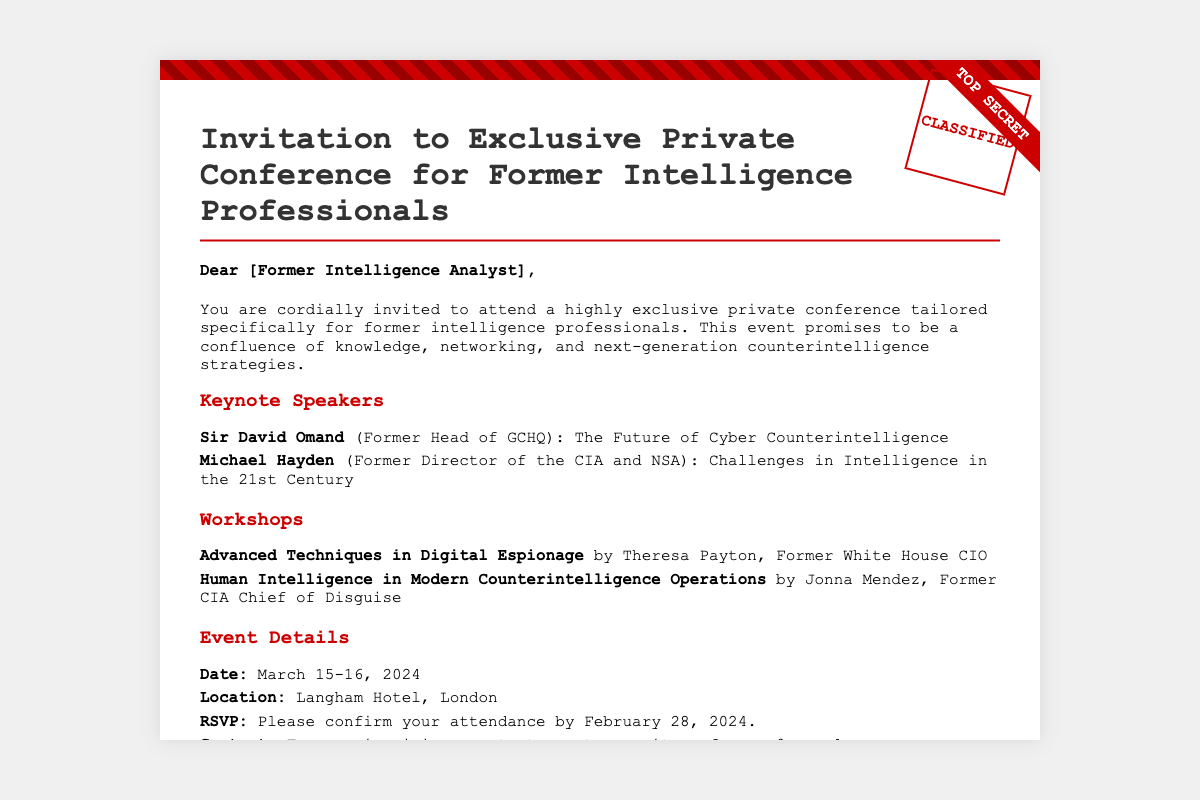What is the date of the conference? The date of the conference is clearly stated in the document under Event Details.
Answer: March 15-16, 2024 Who is the keynote speaker representing GCHQ? The document specifies the keynote speakers, including the one from GCHQ.
Answer: Sir David Omand What is the location of the conference? The location is provided in the Event Details section of the document.
Answer: Langham Hotel, London What workshop is led by the former White House CIO? The document lists workshops, identifying the one led by Theresa Payton.
Answer: Advanced Techniques in Digital Espionage By when do you need to RSVP? The RSVP deadline is mentioned in the Event Details section.
Answer: February 28, 2024 What phrase is used to denote the classification of the invitation? The document includes a stamp that indicates the classification of the invitation.
Answer: CLASSIFIED How many keynote speakers are mentioned? The number of keynote speakers can be counted from the document.
Answer: Two What important topic does Michael Hayden discuss? The document mentions the specific topic that Michael Hayden will address in his keynote speech.
Answer: Challenges in Intelligence in the 21st Century 